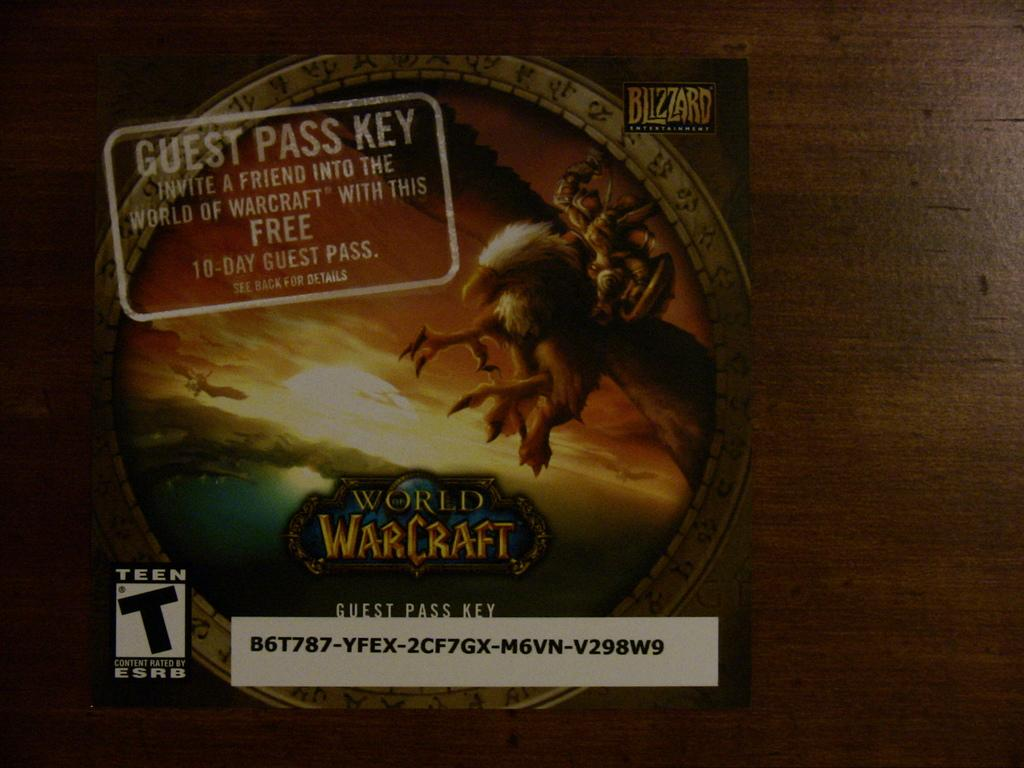<image>
Describe the image concisely. A guest pass key for World of Warcraft. 